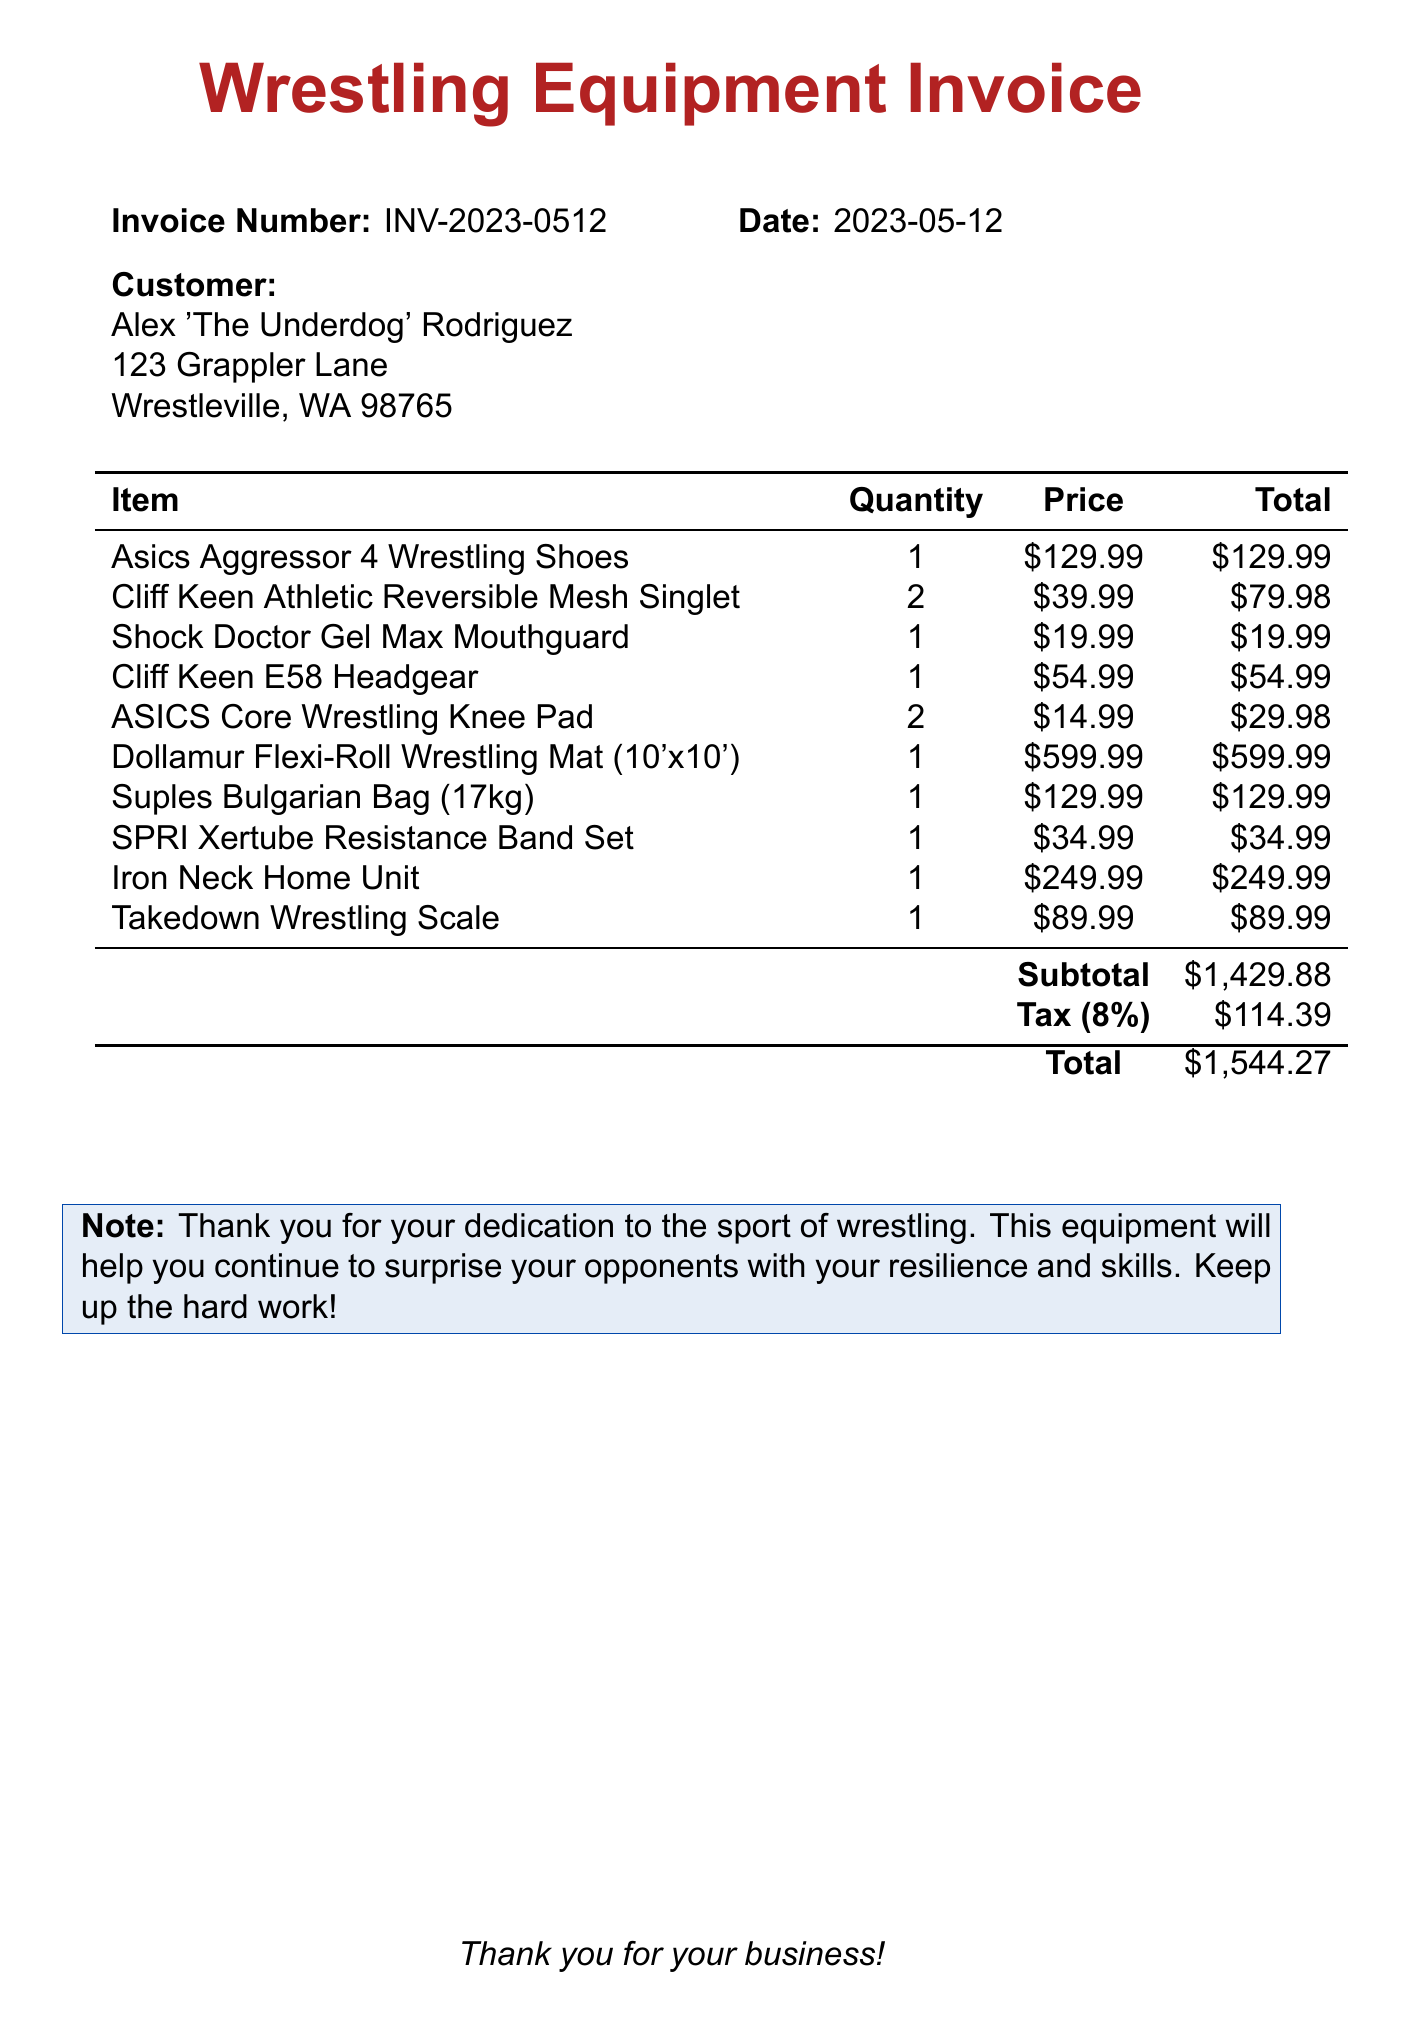What is the invoice number? The invoice number is a unique identifier for the invoice, listed at the top.
Answer: INV-2023-0512 What is the date of the invoice? The date is stated on the invoice to indicate when it was issued.
Answer: 2023-05-12 Who is the customer? The customer's name is provided on the invoice, typically for billing purposes.
Answer: Alex 'The Underdog' Rodriguez How many Cliff Keen Athletic Reversible Mesh Singlets were purchased? The quantity of items purchased is listed in the itemized section of the invoice.
Answer: 2 What is the subtotal amount before tax? The subtotal is the total cost of items before tax is applied, stated at the bottom of the item list.
Answer: $1,429.88 What item has the highest price? This question looks for the most expensive item listed on the invoice.
Answer: Dollamur Flexi-Roll Wrestling Mat (10'x10') What is the tax rate applied to the invoice? The tax rate is indicated in the document and is used to calculate the tax amount.
Answer: 8% What is the total amount due? The total amount combines the subtotal and tax, provided at the end of the invoice.
Answer: $1,544.27 What is the note included in the invoice? The note expresses appreciation to the customer and outlines the purpose of the equipment purchased.
Answer: Thank you for your dedication to the sport of wrestling. This equipment will help you continue to surprise your opponents with your resilience and skills. Keep up the hard work! 